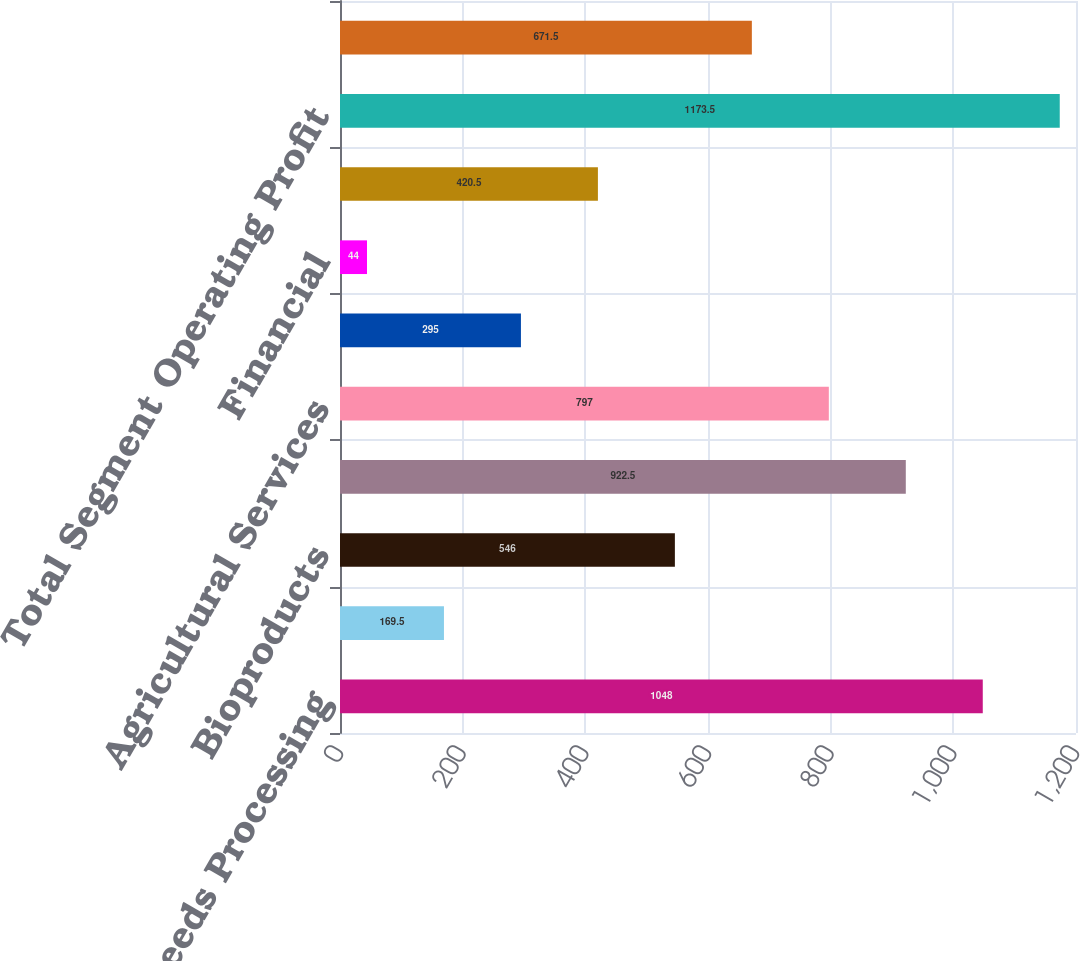Convert chart to OTSL. <chart><loc_0><loc_0><loc_500><loc_500><bar_chart><fcel>Oilseeds Processing<fcel>Sweeteners and Starches<fcel>Bioproducts<fcel>Total Corn Processing<fcel>Agricultural Services<fcel>Food Feed and Industrial<fcel>Financial<fcel>Total Other<fcel>Total Segment Operating Profit<fcel>Corporate<nl><fcel>1048<fcel>169.5<fcel>546<fcel>922.5<fcel>797<fcel>295<fcel>44<fcel>420.5<fcel>1173.5<fcel>671.5<nl></chart> 